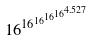<formula> <loc_0><loc_0><loc_500><loc_500>1 6 ^ { 1 6 ^ { 1 6 ^ { 1 6 ^ { 1 6 ^ { 4 . 5 2 7 } } } } }</formula> 